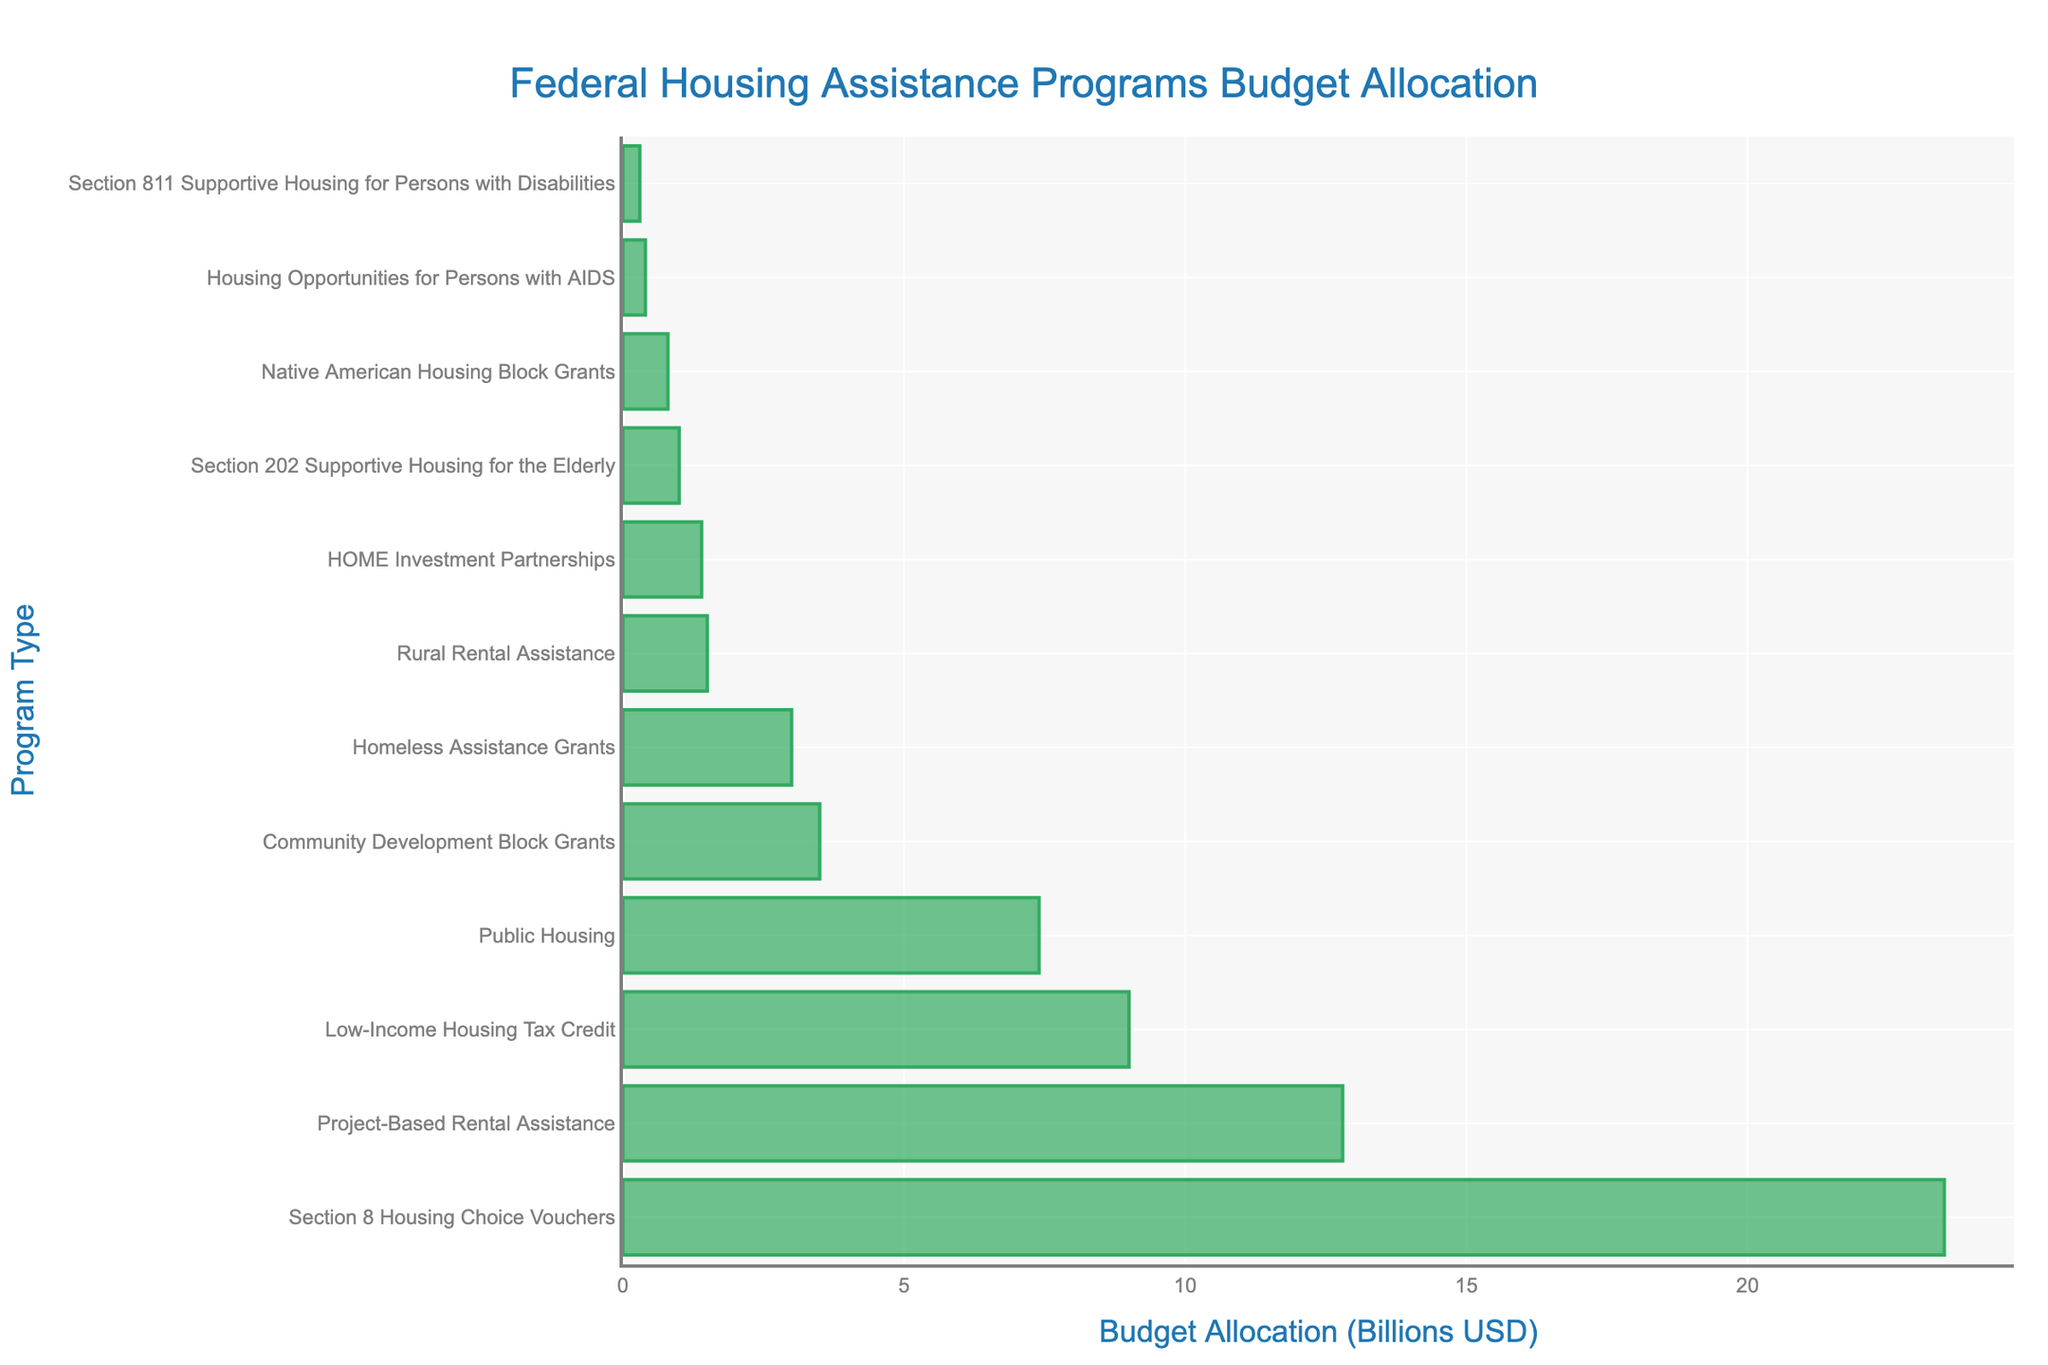What is the program with the highest budget allocation? The program with the highest budget allocation is the one with the longest bar in the chart.
Answer: Section 8 Housing Choice Vouchers Which program has a higher budget allocation: Public Housing or Project-Based Rental Assistance? To compare, look at the length of the bars for Public Housing and Project-Based Rental Assistance. The bar for Project-Based Rental Assistance is longer than the bar for Public Housing.
Answer: Project-Based Rental Assistance What is the combined budget allocation for HOME Investment Partnerships and Homeless Assistance Grants? Add the budget allocations for HOME Investment Partnerships and Homeless Assistance Grants from the chart. HOME Investment Partnerships: $1.4B, Homeless Assistance Grants: $3.0B. So, 1.4 + 3.0 = 4.4.
Answer: 4.4 Billion USD Which programs have a budget allocation of less than 1 Billion USD? Identify the bars representing programs with budget allocations shorter than the 1 Billion USD mark. These are Section 811 Supportive Housing for Persons with Disabilities, Native American Housing Block Grants, and Housing Opportunities for Persons with AIDS.
Answer: Section 811 Supportive Housing for Persons with Disabilities, Native American Housing Block Grants, and Housing Opportunities for Persons with AIDS How much more is allocated to Section 8 Housing Choice Vouchers than Low-Income Housing Tax Credit? Find the budget allocations for both programs and subtract the smaller from the larger. Section 8 Housing Choice Vouchers: $23.5B, Low-Income Housing Tax Credit: $9.0B. So, 23.5 - 9.0 = 14.5.
Answer: 14.5 Billion USD Arrange the programs in ascending order of their budget allocation. Order the programs based on the length of their bars from shortest to longest.
Answer: Section 811 Supportive Housing for Persons with Disabilities, Housing Opportunities for Persons with AIDS, Native American Housing Block Grants, Section 202 Supportive Housing for the Elderly, HOME Investment Partnerships, Rural Rental Assistance, Homeless Assistance Grants, Community Development Block Grants, Public Housing, Low-Income Housing Tax Credit, Project-Based Rental Assistance, Section 8 Housing Choice Vouchers Which program falls right in the middle of the budget allocation spectrum? To find the median program, list all programs in ascending order of their budget allocation and pick the middle one. The order is given in a previous question. Middle program: Section 202 Supportive Housing for the Elderly (1.0B).
Answer: Rural Rental Assistance How many programs have a budget allocation of 1 Billion USD or more? Count the bars that are at least as long as the 1 Billion USD mark. There are 8 programs with a budget allocation of at least 1 Billion USD.
Answer: 8 Which program has the shortest bar in the chart? The shortest bar represents the program with the lowest budget allocation.
Answer: Section 811 Supportive Housing for Persons with Disabilities What is the average budget allocation of all programs? Add the budget allocations of all programs and divide by the number of programs. Total budget = 23.5 + 7.4 + 12.8 + 1.4 + 3.5 + 3.0 + 1.0 + 0.3 + 0.8 + 0.4 + 1.5 + 9.0 = 64.6. Number of programs = 12. Average = 64.6/12 = 5.38.
Answer: 5.38 Billion USD 